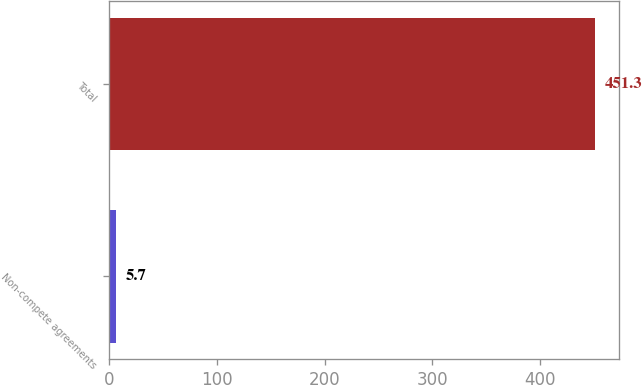<chart> <loc_0><loc_0><loc_500><loc_500><bar_chart><fcel>Non-compete agreements<fcel>Total<nl><fcel>5.7<fcel>451.3<nl></chart> 